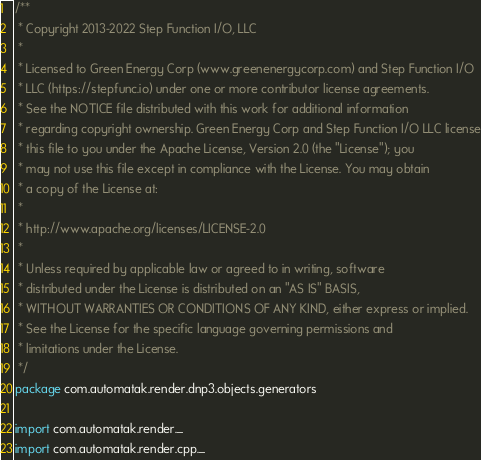<code> <loc_0><loc_0><loc_500><loc_500><_Scala_>/**
 * Copyright 2013-2022 Step Function I/O, LLC
 *
 * Licensed to Green Energy Corp (www.greenenergycorp.com) and Step Function I/O
 * LLC (https://stepfunc.io) under one or more contributor license agreements.
 * See the NOTICE file distributed with this work for additional information
 * regarding copyright ownership. Green Energy Corp and Step Function I/O LLC license
 * this file to you under the Apache License, Version 2.0 (the "License"); you
 * may not use this file except in compliance with the License. You may obtain
 * a copy of the License at:
 *
 * http://www.apache.org/licenses/LICENSE-2.0
 *
 * Unless required by applicable law or agreed to in writing, software
 * distributed under the License is distributed on an "AS IS" BASIS,
 * WITHOUT WARRANTIES OR CONDITIONS OF ANY KIND, either express or implied.
 * See the License for the specific language governing permissions and
 * limitations under the License.
 */
package com.automatak.render.dnp3.objects.generators

import com.automatak.render._
import com.automatak.render.cpp._</code> 